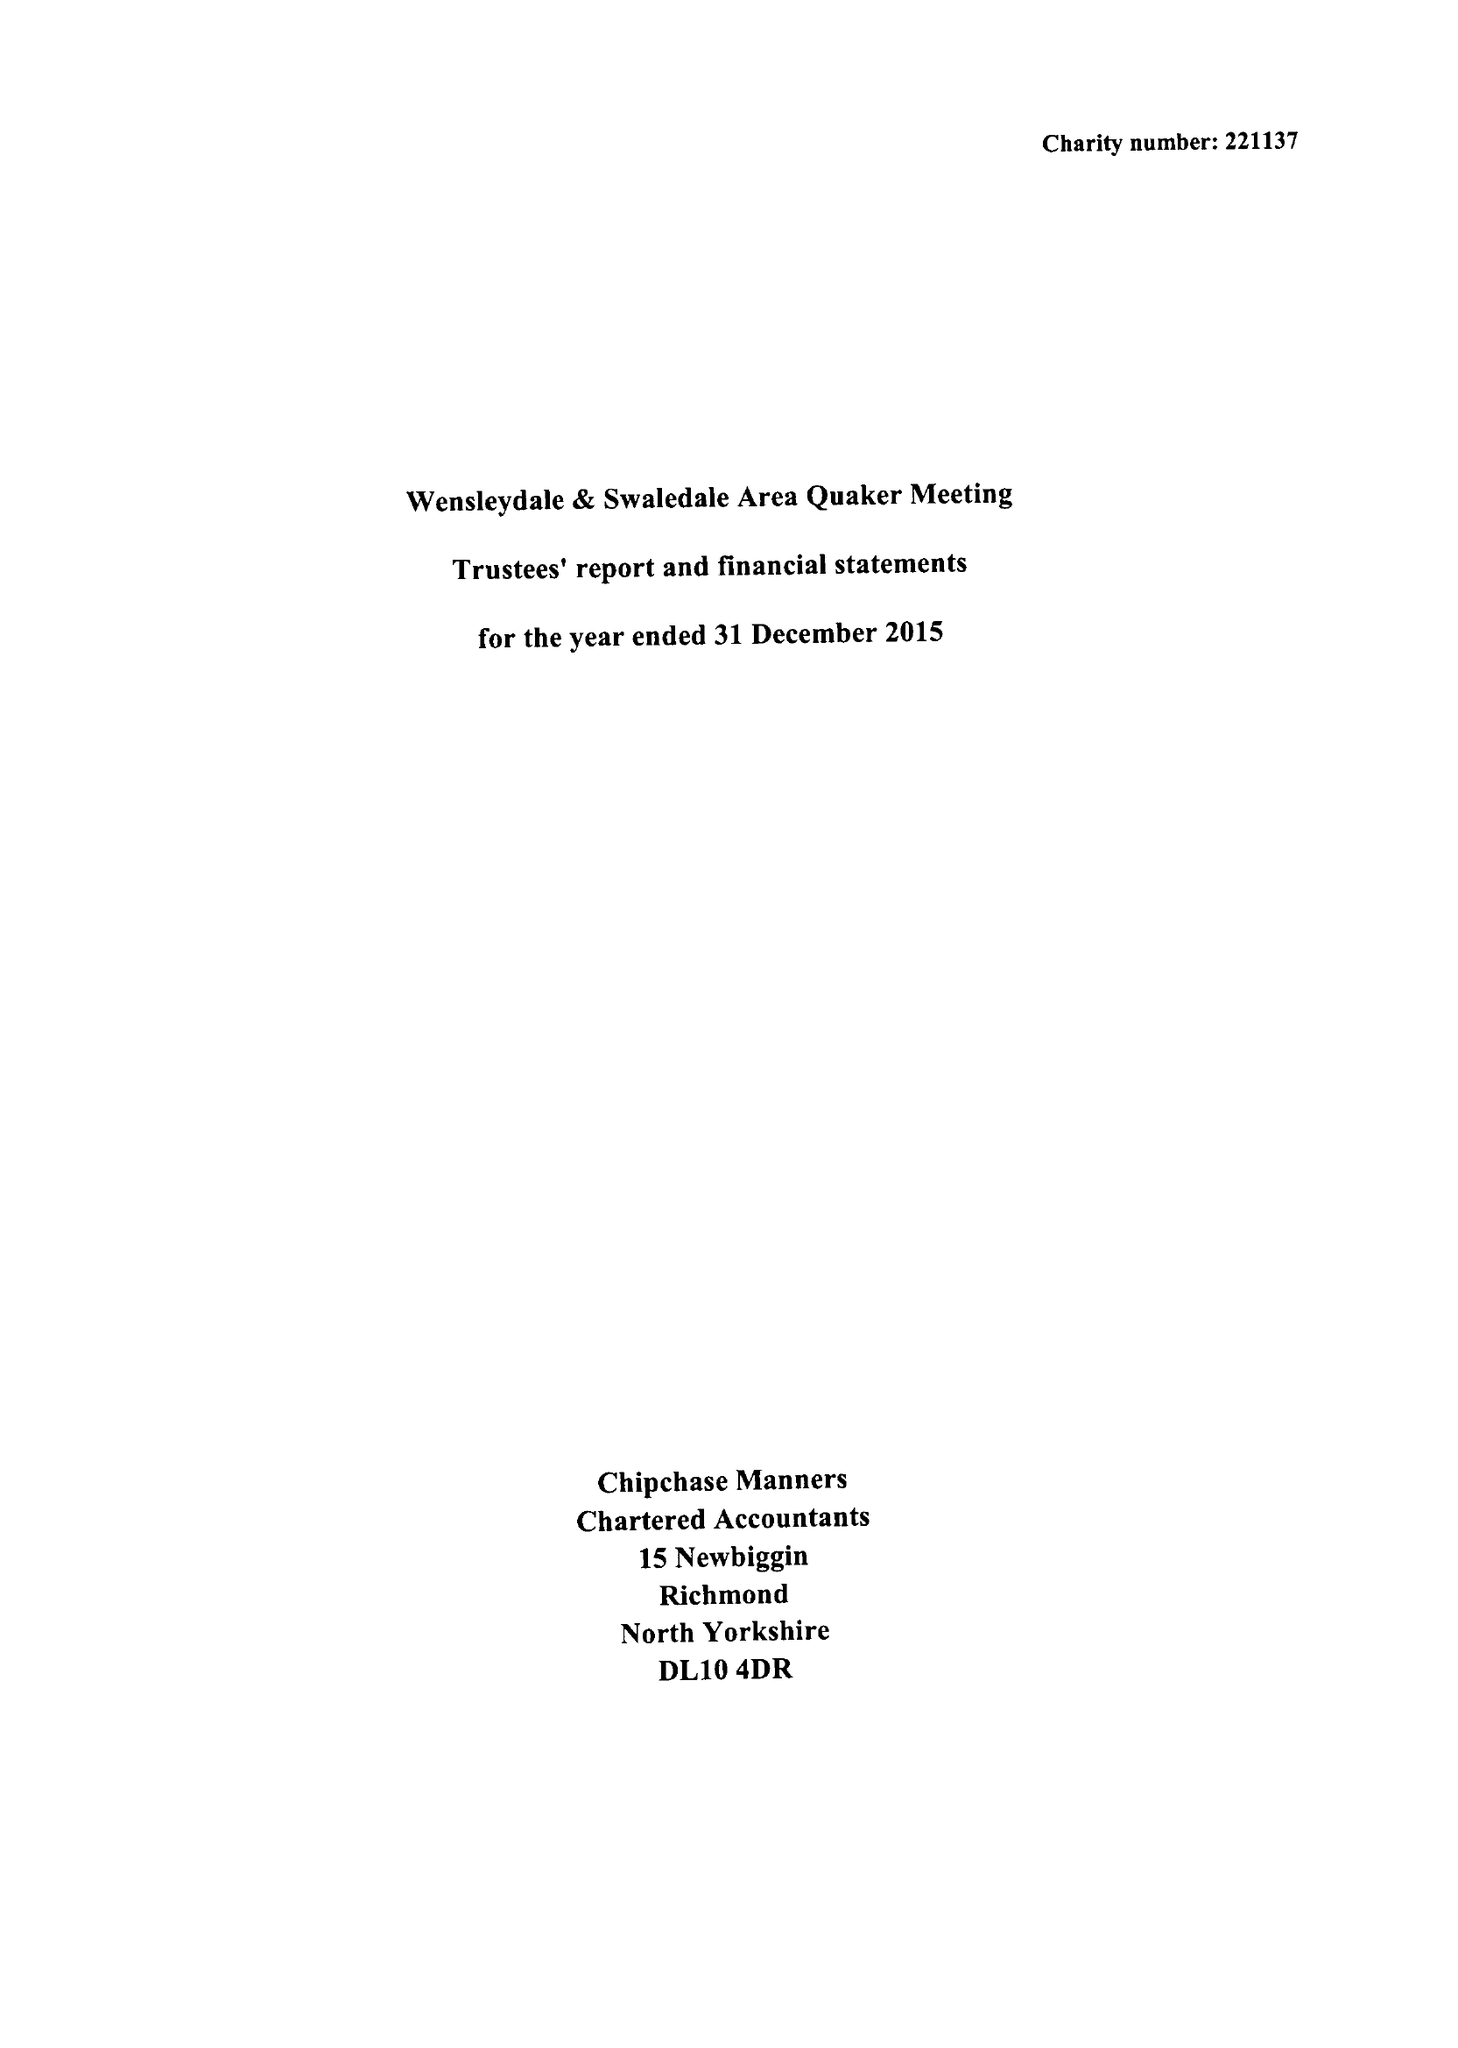What is the value for the address__street_line?
Answer the question using a single word or phrase. 7 GROVE SQUARE 